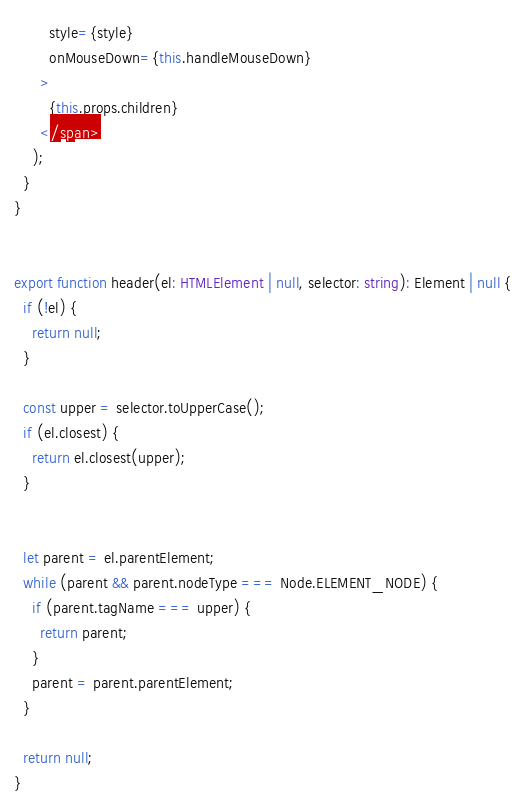Convert code to text. <code><loc_0><loc_0><loc_500><loc_500><_TypeScript_>        style={style}
        onMouseDown={this.handleMouseDown}
      >
        {this.props.children}
      </span>
    );
  }
}


export function header(el: HTMLElement | null, selector: string): Element | null {
  if (!el) {
    return null;
  }

  const upper = selector.toUpperCase();
  if (el.closest) {
    return el.closest(upper);
  }


  let parent = el.parentElement;
  while (parent && parent.nodeType === Node.ELEMENT_NODE) {
    if (parent.tagName === upper) {
      return parent;
    }
    parent = parent.parentElement;
  }

  return null;
}
</code> 